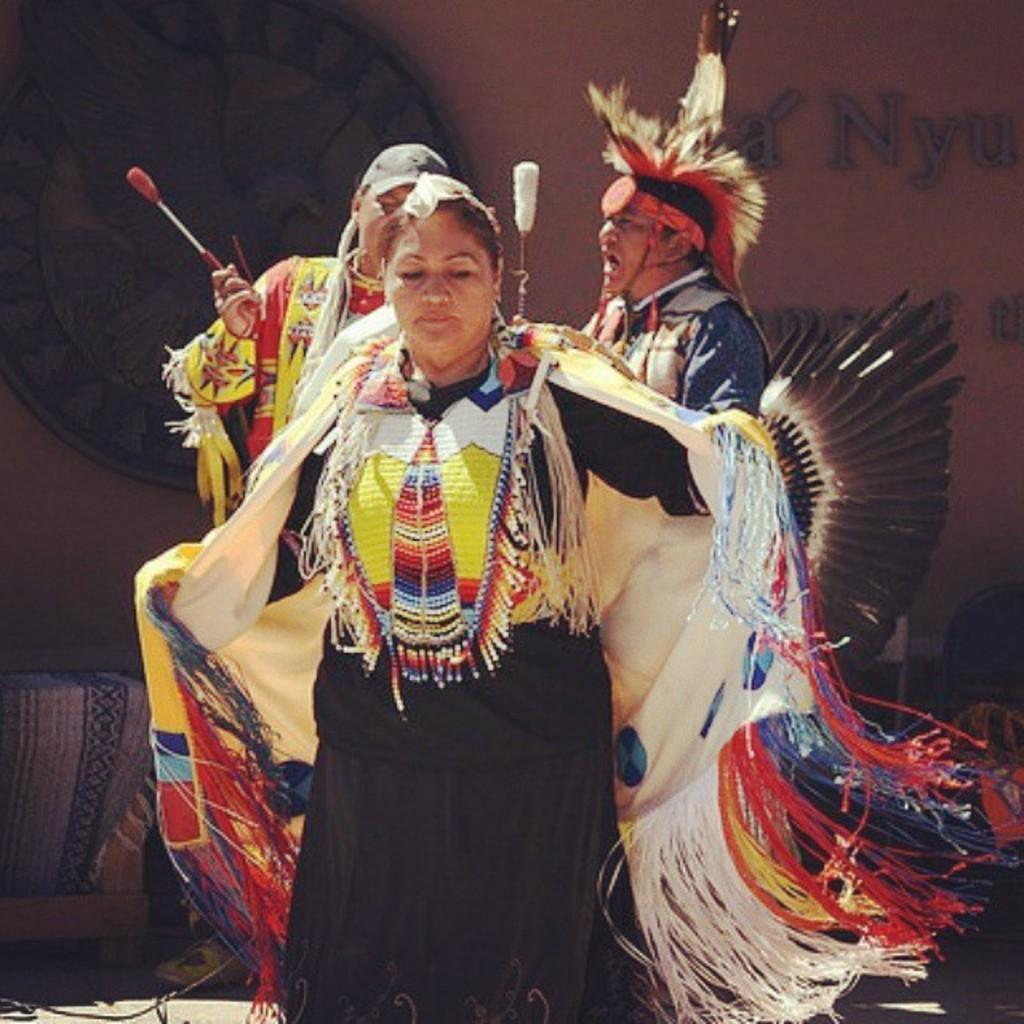What is happening in the center of the image? There are people in the center of the image. What are the people wearing? The people are wearing costumes. What can be seen on the left side of the image? There is a portrait on the left side of the image. What might the people be doing in the image? The people appear to be dancing. How many teeth can be seen in the portrait on the left side of the image? There are no teeth visible in the portrait on the left side of the image, as it is not a close-up of a face. 